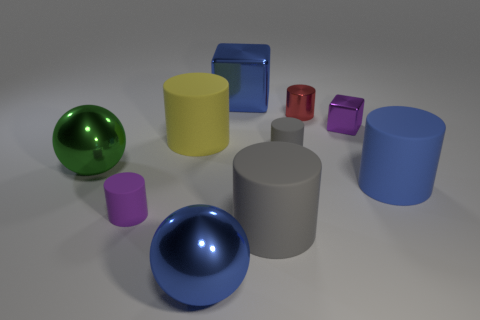Subtract all red blocks. How many gray cylinders are left? 2 Subtract all blue cylinders. How many cylinders are left? 5 Subtract all purple cylinders. How many cylinders are left? 5 Subtract all cubes. How many objects are left? 8 Subtract all red cylinders. Subtract all green blocks. How many cylinders are left? 5 Subtract all shiny objects. Subtract all tiny purple shiny things. How many objects are left? 4 Add 8 purple shiny things. How many purple shiny things are left? 9 Add 3 big cubes. How many big cubes exist? 4 Subtract 0 red cubes. How many objects are left? 10 